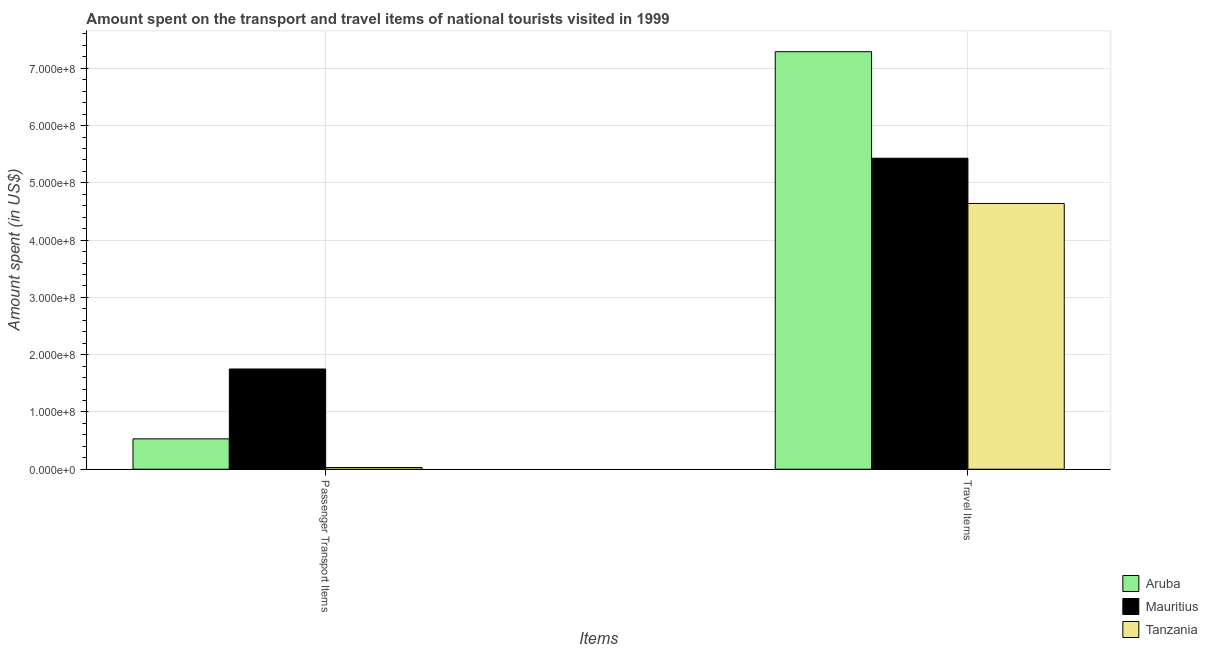How many bars are there on the 2nd tick from the right?
Provide a succinct answer. 3. What is the label of the 1st group of bars from the left?
Ensure brevity in your answer.  Passenger Transport Items. What is the amount spent in travel items in Aruba?
Your response must be concise. 7.29e+08. Across all countries, what is the maximum amount spent in travel items?
Provide a short and direct response. 7.29e+08. Across all countries, what is the minimum amount spent on passenger transport items?
Offer a very short reply. 3.00e+06. In which country was the amount spent in travel items maximum?
Provide a short and direct response. Aruba. In which country was the amount spent on passenger transport items minimum?
Provide a short and direct response. Tanzania. What is the total amount spent in travel items in the graph?
Provide a succinct answer. 1.74e+09. What is the difference between the amount spent on passenger transport items in Mauritius and that in Tanzania?
Provide a succinct answer. 1.72e+08. What is the difference between the amount spent on passenger transport items in Aruba and the amount spent in travel items in Tanzania?
Provide a short and direct response. -4.11e+08. What is the average amount spent on passenger transport items per country?
Your answer should be compact. 7.70e+07. What is the difference between the amount spent on passenger transport items and amount spent in travel items in Mauritius?
Offer a very short reply. -3.68e+08. In how many countries, is the amount spent on passenger transport items greater than 560000000 US$?
Your answer should be compact. 0. What is the ratio of the amount spent on passenger transport items in Aruba to that in Tanzania?
Your response must be concise. 17.67. Is the amount spent in travel items in Aruba less than that in Tanzania?
Offer a terse response. No. What does the 1st bar from the left in Travel Items represents?
Give a very brief answer. Aruba. What does the 1st bar from the right in Passenger Transport Items represents?
Provide a short and direct response. Tanzania. How many bars are there?
Give a very brief answer. 6. Are all the bars in the graph horizontal?
Your answer should be compact. No. What is the difference between two consecutive major ticks on the Y-axis?
Your answer should be compact. 1.00e+08. Are the values on the major ticks of Y-axis written in scientific E-notation?
Your response must be concise. Yes. Does the graph contain any zero values?
Ensure brevity in your answer.  No. What is the title of the graph?
Keep it short and to the point. Amount spent on the transport and travel items of national tourists visited in 1999. Does "Egypt, Arab Rep." appear as one of the legend labels in the graph?
Keep it short and to the point. No. What is the label or title of the X-axis?
Ensure brevity in your answer.  Items. What is the label or title of the Y-axis?
Give a very brief answer. Amount spent (in US$). What is the Amount spent (in US$) in Aruba in Passenger Transport Items?
Ensure brevity in your answer.  5.30e+07. What is the Amount spent (in US$) of Mauritius in Passenger Transport Items?
Your answer should be compact. 1.75e+08. What is the Amount spent (in US$) of Aruba in Travel Items?
Ensure brevity in your answer.  7.29e+08. What is the Amount spent (in US$) of Mauritius in Travel Items?
Your answer should be compact. 5.43e+08. What is the Amount spent (in US$) of Tanzania in Travel Items?
Your answer should be compact. 4.64e+08. Across all Items, what is the maximum Amount spent (in US$) of Aruba?
Your response must be concise. 7.29e+08. Across all Items, what is the maximum Amount spent (in US$) in Mauritius?
Make the answer very short. 5.43e+08. Across all Items, what is the maximum Amount spent (in US$) of Tanzania?
Offer a terse response. 4.64e+08. Across all Items, what is the minimum Amount spent (in US$) in Aruba?
Provide a succinct answer. 5.30e+07. Across all Items, what is the minimum Amount spent (in US$) in Mauritius?
Offer a terse response. 1.75e+08. What is the total Amount spent (in US$) of Aruba in the graph?
Provide a succinct answer. 7.82e+08. What is the total Amount spent (in US$) in Mauritius in the graph?
Provide a succinct answer. 7.18e+08. What is the total Amount spent (in US$) of Tanzania in the graph?
Ensure brevity in your answer.  4.67e+08. What is the difference between the Amount spent (in US$) in Aruba in Passenger Transport Items and that in Travel Items?
Ensure brevity in your answer.  -6.76e+08. What is the difference between the Amount spent (in US$) in Mauritius in Passenger Transport Items and that in Travel Items?
Your answer should be compact. -3.68e+08. What is the difference between the Amount spent (in US$) of Tanzania in Passenger Transport Items and that in Travel Items?
Your answer should be compact. -4.61e+08. What is the difference between the Amount spent (in US$) in Aruba in Passenger Transport Items and the Amount spent (in US$) in Mauritius in Travel Items?
Your answer should be compact. -4.90e+08. What is the difference between the Amount spent (in US$) of Aruba in Passenger Transport Items and the Amount spent (in US$) of Tanzania in Travel Items?
Offer a very short reply. -4.11e+08. What is the difference between the Amount spent (in US$) in Mauritius in Passenger Transport Items and the Amount spent (in US$) in Tanzania in Travel Items?
Offer a very short reply. -2.89e+08. What is the average Amount spent (in US$) of Aruba per Items?
Provide a succinct answer. 3.91e+08. What is the average Amount spent (in US$) in Mauritius per Items?
Your response must be concise. 3.59e+08. What is the average Amount spent (in US$) of Tanzania per Items?
Give a very brief answer. 2.34e+08. What is the difference between the Amount spent (in US$) of Aruba and Amount spent (in US$) of Mauritius in Passenger Transport Items?
Your answer should be very brief. -1.22e+08. What is the difference between the Amount spent (in US$) in Mauritius and Amount spent (in US$) in Tanzania in Passenger Transport Items?
Your answer should be very brief. 1.72e+08. What is the difference between the Amount spent (in US$) in Aruba and Amount spent (in US$) in Mauritius in Travel Items?
Keep it short and to the point. 1.86e+08. What is the difference between the Amount spent (in US$) in Aruba and Amount spent (in US$) in Tanzania in Travel Items?
Keep it short and to the point. 2.65e+08. What is the difference between the Amount spent (in US$) of Mauritius and Amount spent (in US$) of Tanzania in Travel Items?
Keep it short and to the point. 7.90e+07. What is the ratio of the Amount spent (in US$) of Aruba in Passenger Transport Items to that in Travel Items?
Offer a terse response. 0.07. What is the ratio of the Amount spent (in US$) of Mauritius in Passenger Transport Items to that in Travel Items?
Provide a short and direct response. 0.32. What is the ratio of the Amount spent (in US$) of Tanzania in Passenger Transport Items to that in Travel Items?
Offer a very short reply. 0.01. What is the difference between the highest and the second highest Amount spent (in US$) in Aruba?
Offer a terse response. 6.76e+08. What is the difference between the highest and the second highest Amount spent (in US$) of Mauritius?
Ensure brevity in your answer.  3.68e+08. What is the difference between the highest and the second highest Amount spent (in US$) in Tanzania?
Ensure brevity in your answer.  4.61e+08. What is the difference between the highest and the lowest Amount spent (in US$) of Aruba?
Your answer should be very brief. 6.76e+08. What is the difference between the highest and the lowest Amount spent (in US$) in Mauritius?
Offer a terse response. 3.68e+08. What is the difference between the highest and the lowest Amount spent (in US$) of Tanzania?
Give a very brief answer. 4.61e+08. 